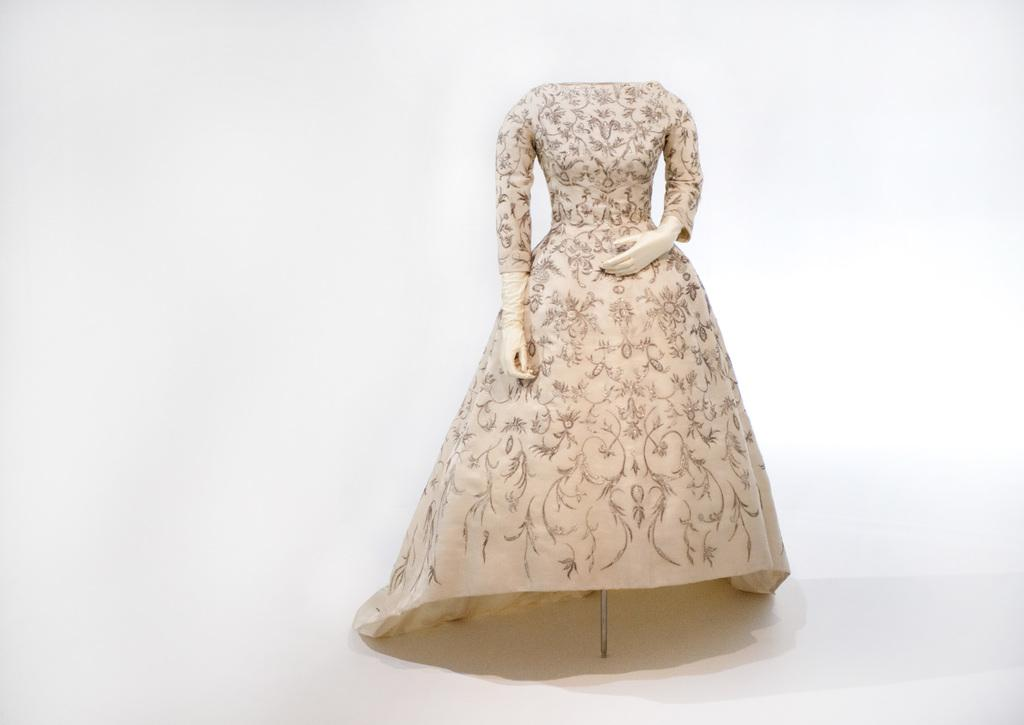Who is present in the image? There is a woman in the image. What other object can be seen in the image? There is a mannequin in the image. What type of crime is being committed by the woman in the image? There is no indication of a crime being committed in the image; it only shows a woman and a mannequin. 